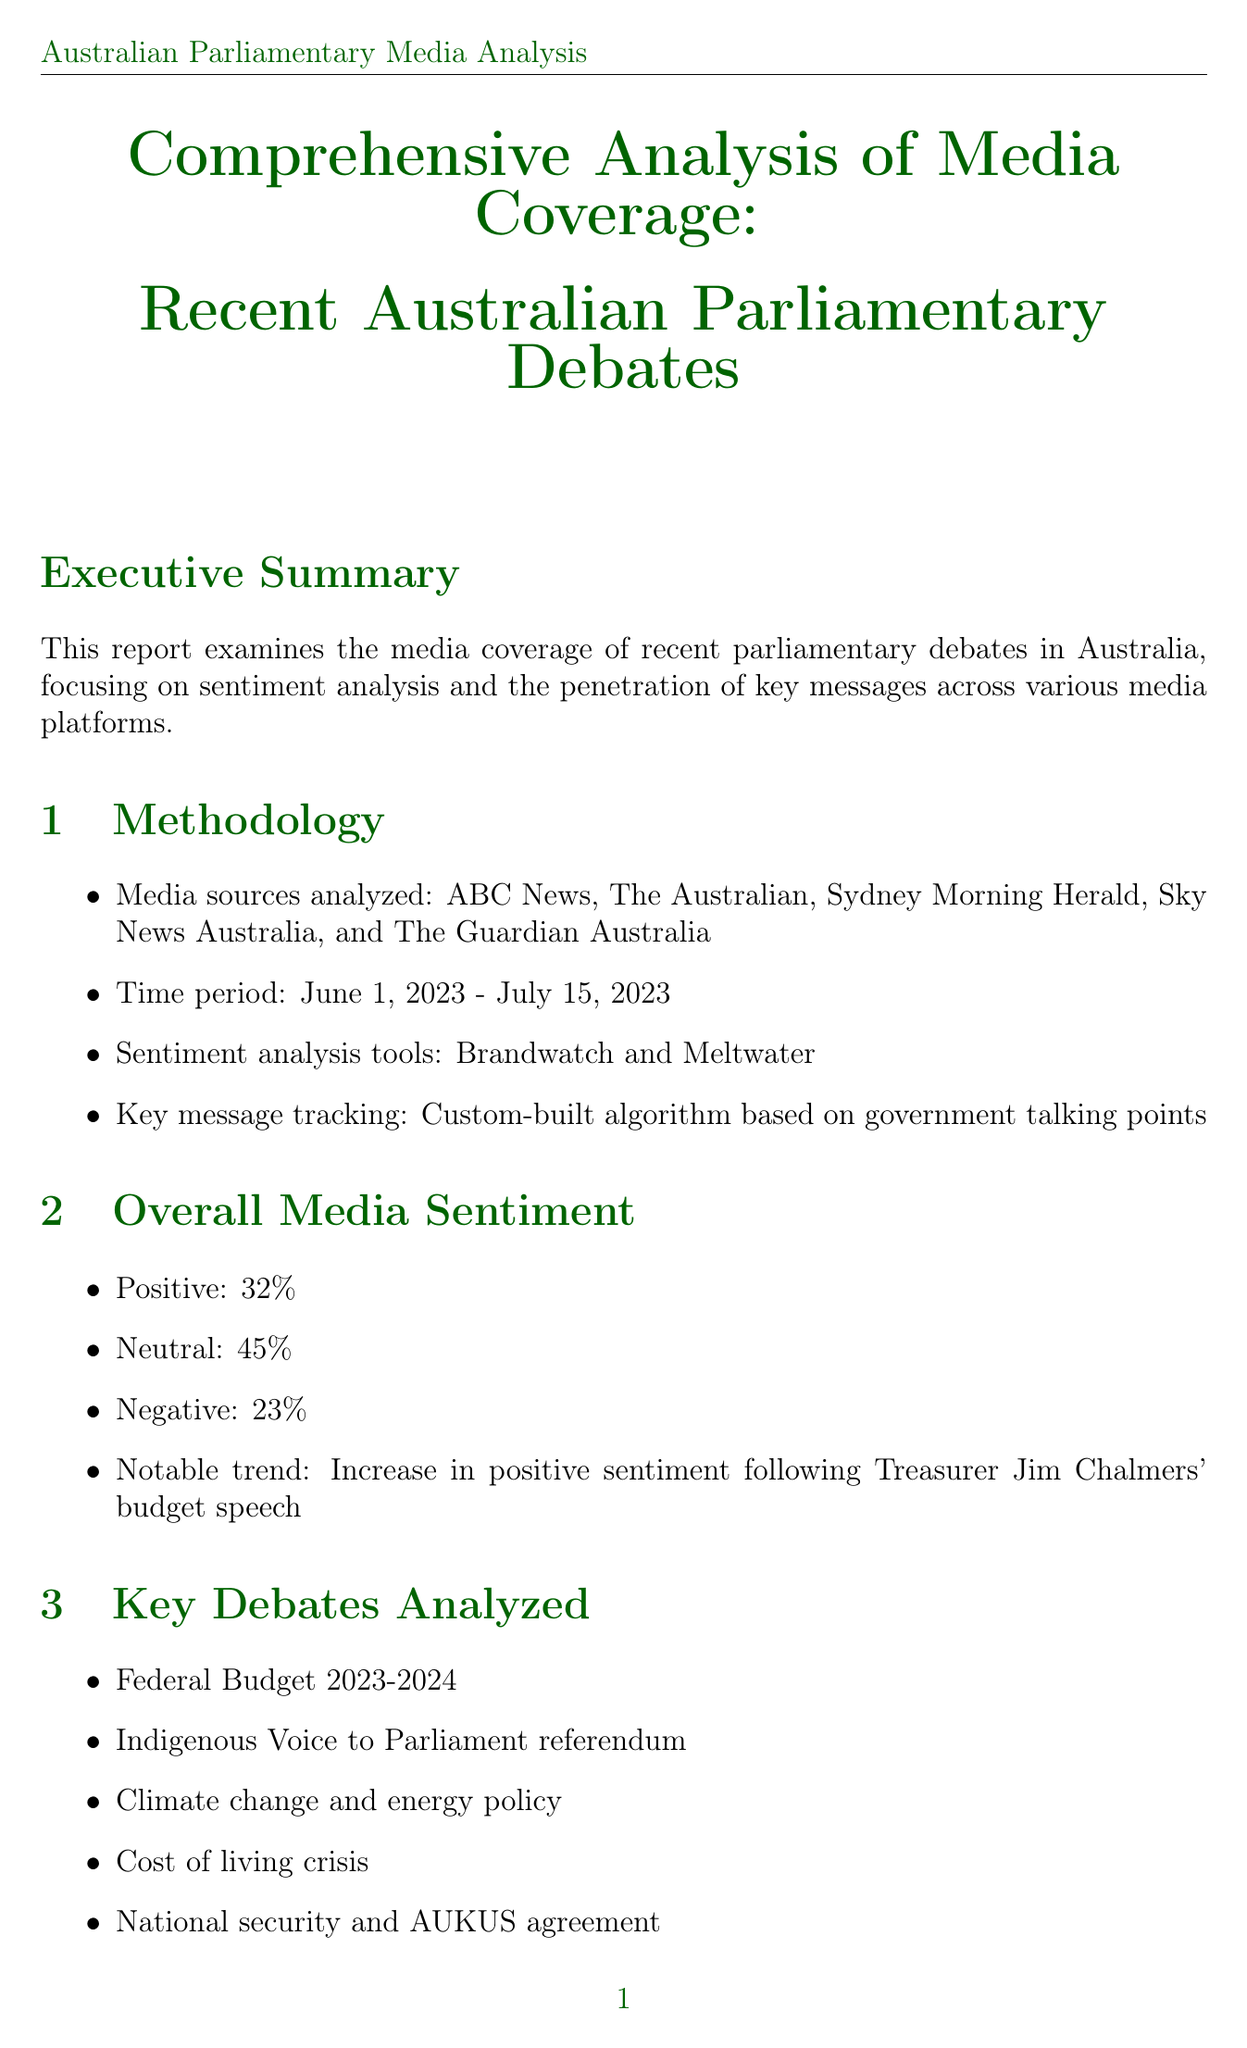What is the time period of the analysis? The time period for the media coverage analysis is specified in the methodology section of the document.
Answer: June 1, 2023 - July 15, 2023 What percentage of media sentiment was positive? The overall media sentiment section provides a breakdown of sentiment percentages related to recent parliamentary debates.
Answer: 32% Which media source is included in the analysis? The methodology section lists various media sources that were analyzed for the report.
Answer: ABC News What is the penetration rate for the constitutional recognition for Indigenous Australians? This information is found in the key message penetration section of the report, which presents penetration percentages for specific messages.
Answer: 85% penetration Which political party received 52% positive coverage? The political party performance section details the positive media coverage percentages for various political parties.
Answer: Australian Labor Party What emphasis was noted in Western Australia regarding media coverage? The regional variations section highlights specific regional focuses for media coverage of parliamentary debates.
Answer: Mining and resources policy What social media platform is described as the most engaged for real-time debate reactions? The social media impact section identifies which platform had the highest engagement during parliamentary debates.
Answer: Twitter What is one of the recommendations made in the report? The recommendations section provides suggested actions to improve media coverage and sentiment.
Answer: Increase focus on positive economic messaging across all media platforms 